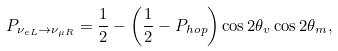<formula> <loc_0><loc_0><loc_500><loc_500>P _ { \nu _ { e L } \rightarrow \nu _ { \mu R } } = \frac { 1 } { 2 } - \left ( \frac { 1 } { 2 } - P _ { h o p } \right ) \cos 2 \theta _ { v } \cos 2 \theta _ { m } ,</formula> 